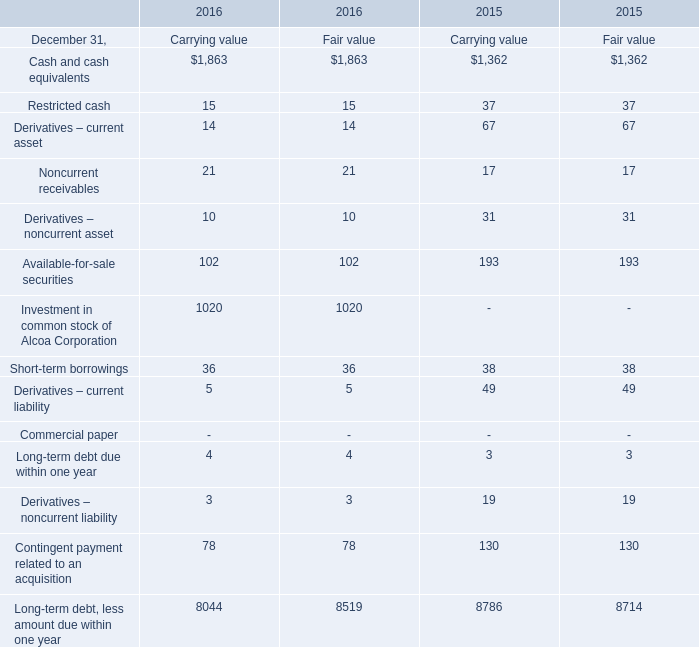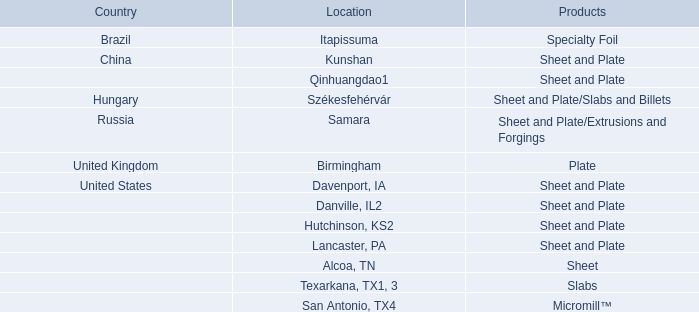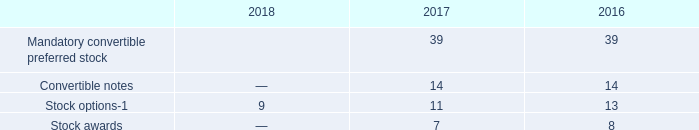considering the average exercise price of options , what is the estimated total value of stock options in 2018 , in millions of dollars? 
Computations: (9 * 26.79)
Answer: 241.11. 